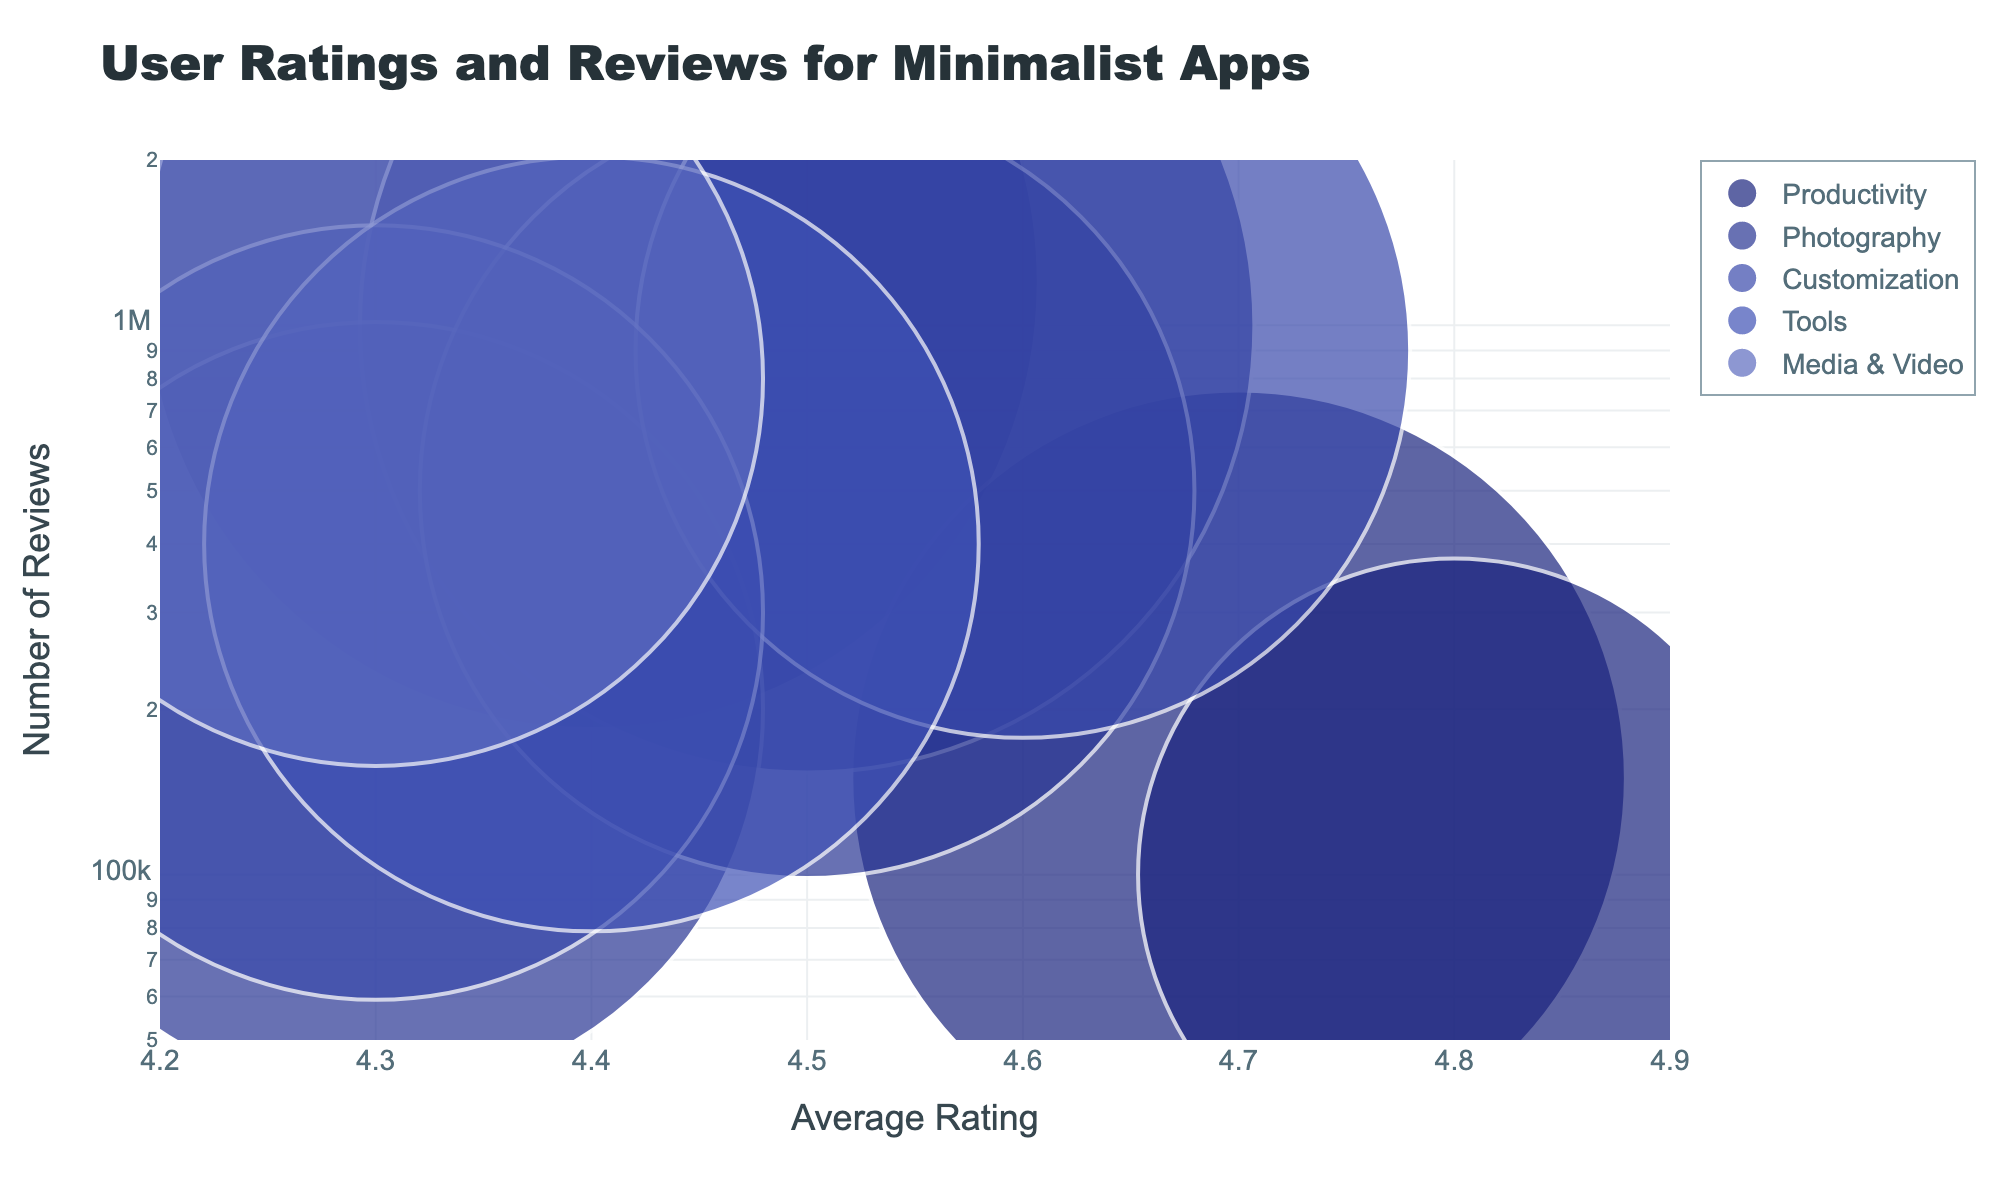What are the categories represented in the bubble chart? The categories are displayed as bubble groups with various colors. By looking at the legend in the chart, you can see the names of all the categories represented.
Answer: Productivity, Photography, Customization, Tools, Media & Video What is the range of the x-axis in the chart? The x-axis represents the average rating, and its range is given in the figure. By observing the axis, you can identify the minimum and maximum values.
Answer: 4.2 to 4.9 Which app has the highest average rating? Each bubble represents an app, and its position on the x-axis shows the average rating. By checking the app with the highest position on the x-axis, we can determine the highest average rating.
Answer: Writero How many reviews does Google Keep have? Locate the Google Keep bubble on the plot, hover over it or check the y-axis value directly. The y-axis represents the number of reviews.
Answer: 1,200,000 Which app has the largest-sized bubble? Bubble size represents the bubble size column. Check which bubble appears largest visually in the plot.
Answer: Google Keep and Snapseed How does the number of reviews for Nova Launcher compare to Evie Launcher? Find the bubbles for Nova Launcher and Evie Launcher, and compare their positions on the y-axis which represents the number of reviews.
Answer: Nova Launcher has more reviews than Evie Launcher What is the y-axis type, and why might that be important? The label and scale type of the y-axis can be identified by looking at the axis line. This aspect might impact how we perceive the distribution of reviews.
Answer: Logarithmic, it helps to display a wide range of review counts more effectively What colors are used to represent different categories? Different categories are color-coded. By referring to the legend, the specific colors can be identified.
Answer: Shades of blue Which category contains the app with the second-highest average rating? Identify apps and their categories, and then determine which category contains the app with the second-highest x-axis position.
Answer: Productivity What range of number of reviews is most common for the apps displayed? Examine the concentration of bubbles along the y-axis to understand the most frequent range of review counts among the apps.
Answer: 100,000 to 1,000,000 